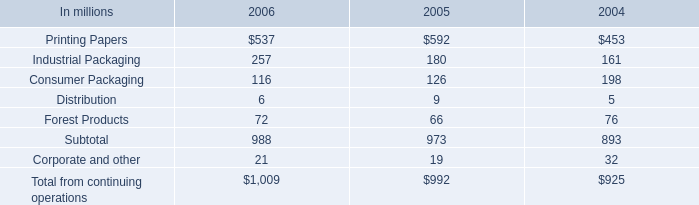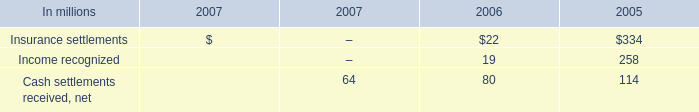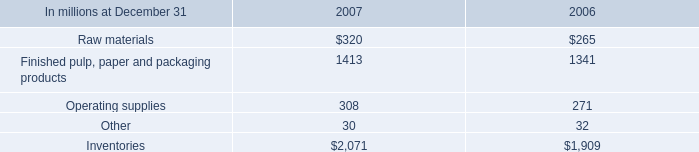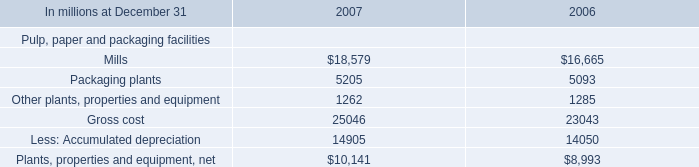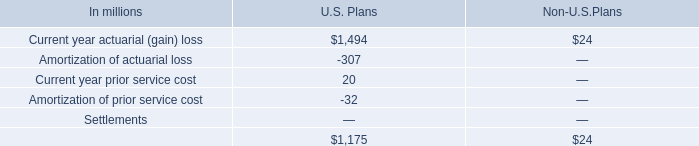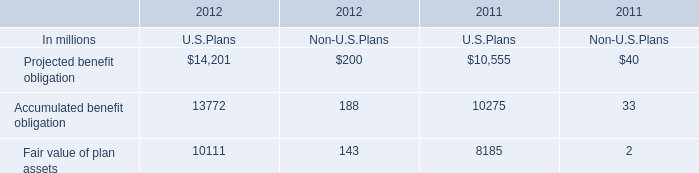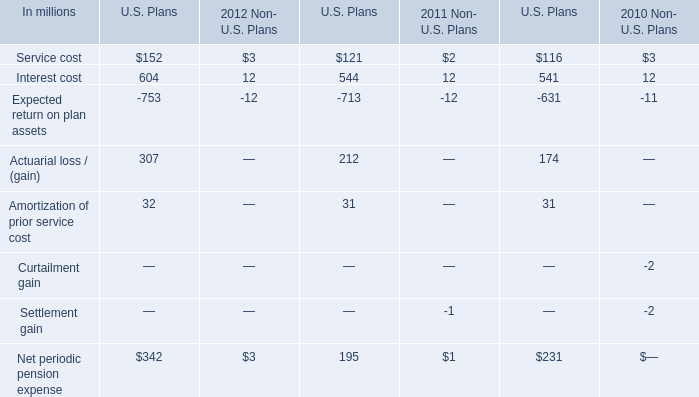What is the percentage of all Accumulated benefit obligation that are positive to the total amount, in 2012? 
Computations: ((13772 + 188) / (((((13772 + 188) + 14201) + 200) + 10111) + 143))
Answer: 0.36152. 